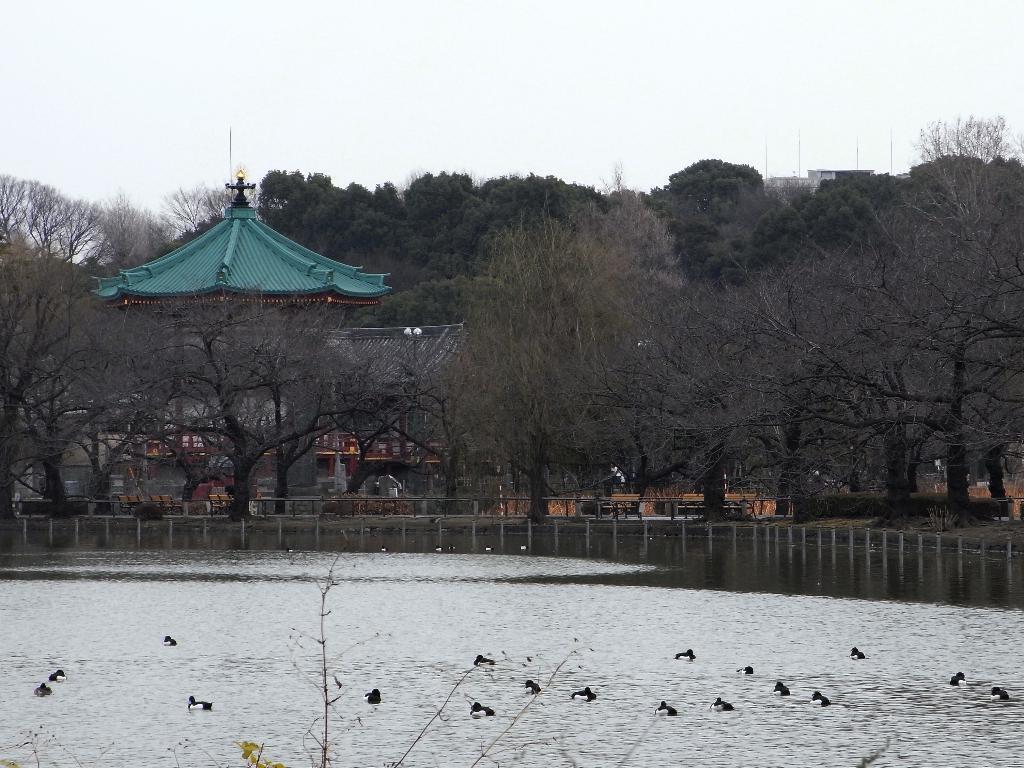How would you summarize this image in a sentence or two? In the background we can see the sky, trees and a building. In this picture we can see poles, objects, water and birds. At the bottom portion of the picture we can see branches. 